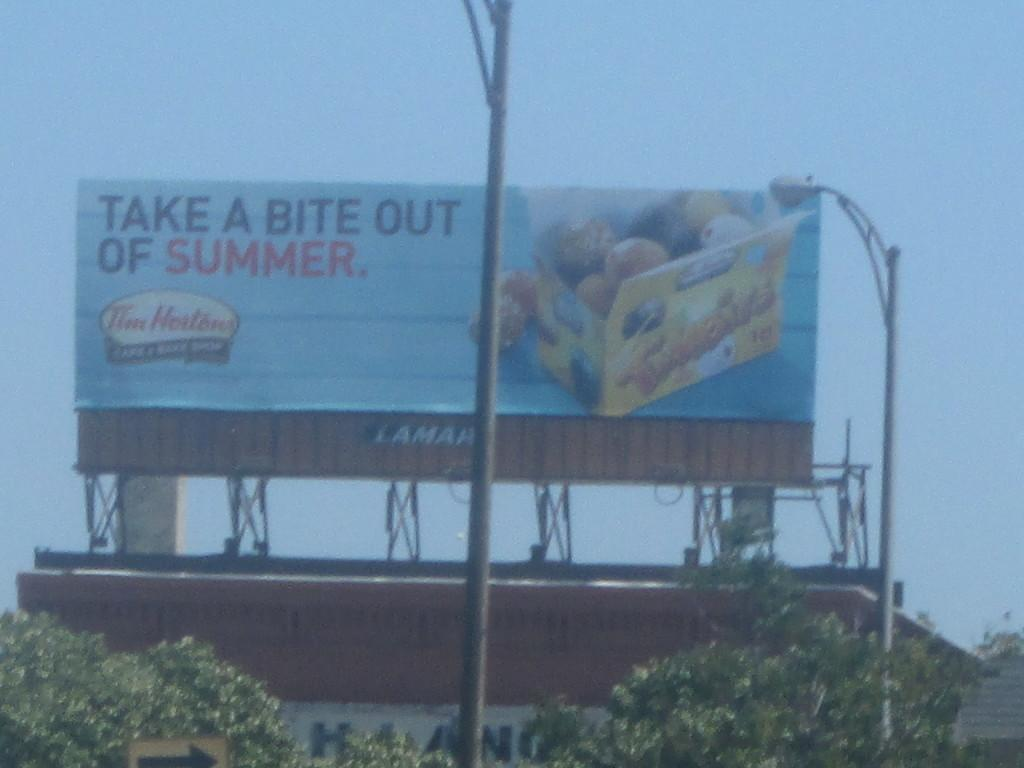<image>
Share a concise interpretation of the image provided. A billboard for Tim Hortons advises you to Take a bite out of summer. 